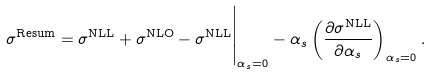<formula> <loc_0><loc_0><loc_500><loc_500>\sigma ^ { \text {Resum} } = \sigma ^ { \text {NLL} } + \sigma ^ { \text {NLO} } - \sigma ^ { \text {NLL} } \Big | _ { \alpha _ { s } = 0 } - \alpha _ { s } \left ( \frac { \partial \sigma ^ { \text {NLL} } } { \partial \alpha _ { s } } \right ) _ { \alpha _ { s } = 0 } .</formula> 